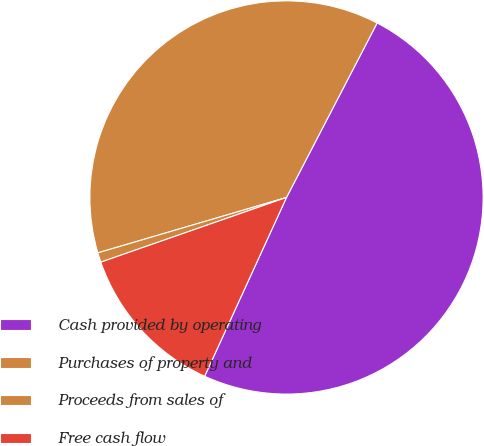Convert chart to OTSL. <chart><loc_0><loc_0><loc_500><loc_500><pie_chart><fcel>Cash provided by operating<fcel>Purchases of property and<fcel>Proceeds from sales of<fcel>Free cash flow<nl><fcel>49.21%<fcel>37.17%<fcel>0.79%<fcel>12.83%<nl></chart> 